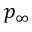<formula> <loc_0><loc_0><loc_500><loc_500>p _ { \infty }</formula> 